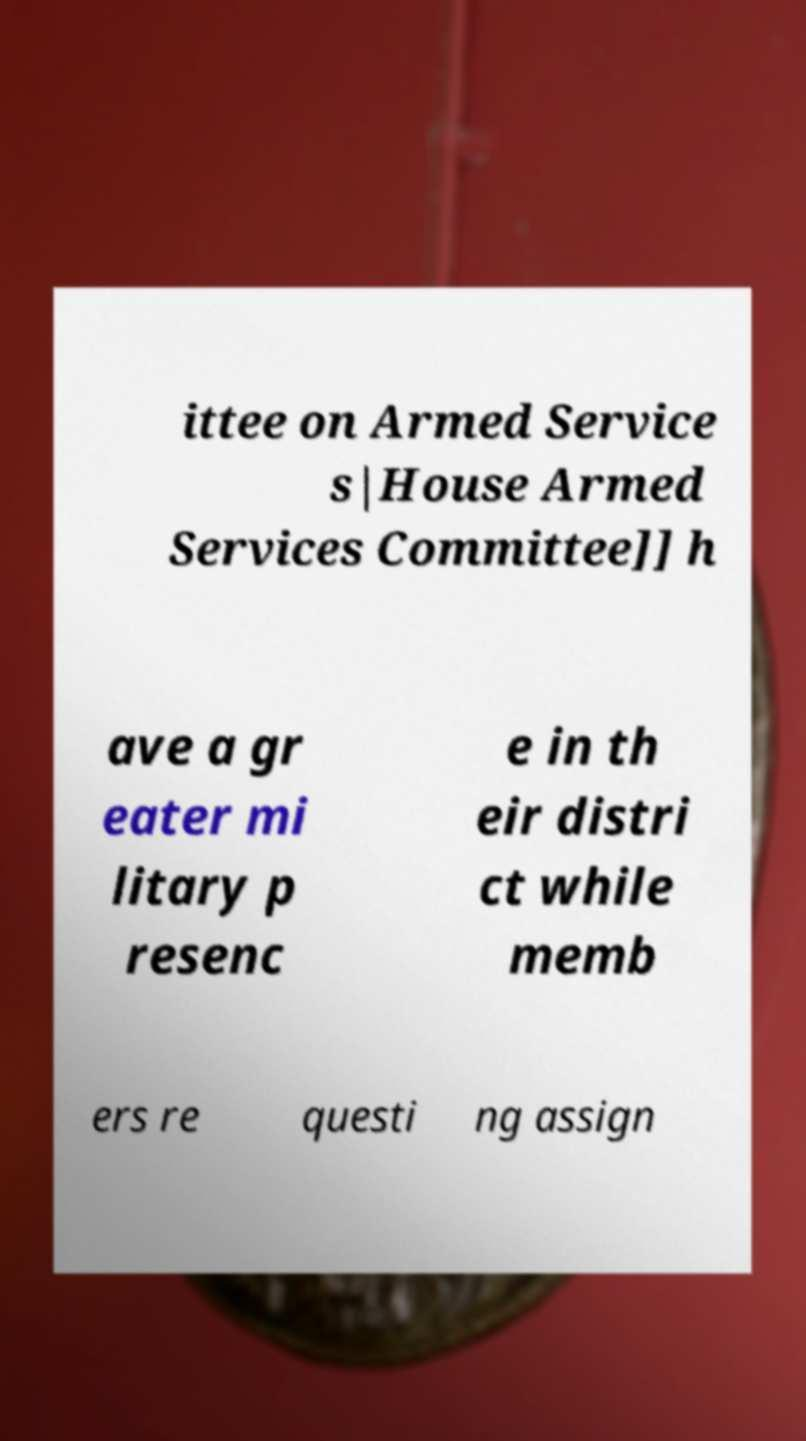For documentation purposes, I need the text within this image transcribed. Could you provide that? ittee on Armed Service s|House Armed Services Committee]] h ave a gr eater mi litary p resenc e in th eir distri ct while memb ers re questi ng assign 